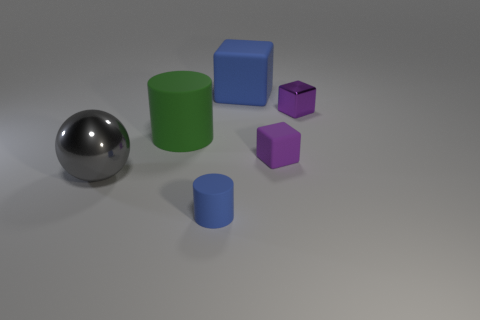Does the lighting indicate a light source within the scene? Yes, the shadows and highlights on the objects suggest that there is a light source above and to the left of the scene, which is not visible in the frame. 